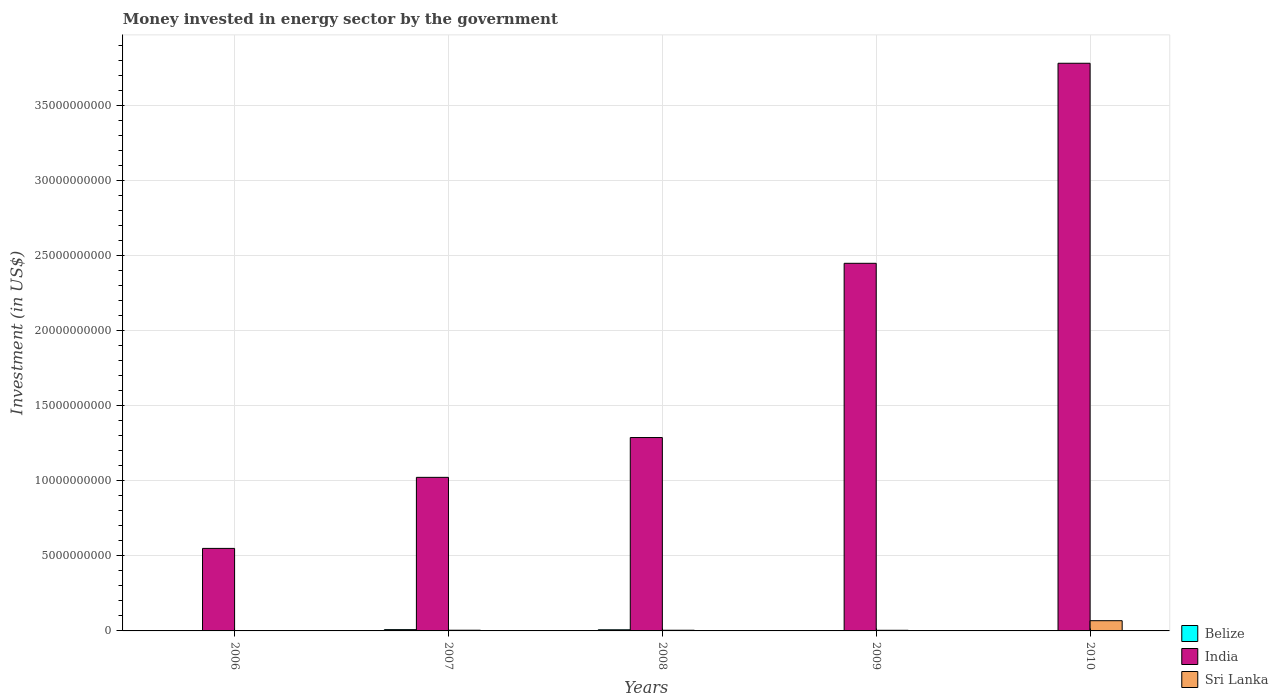Are the number of bars per tick equal to the number of legend labels?
Make the answer very short. Yes. What is the label of the 1st group of bars from the left?
Keep it short and to the point. 2006. In how many cases, is the number of bars for a given year not equal to the number of legend labels?
Provide a succinct answer. 0. What is the money spent in energy sector in Sri Lanka in 2008?
Your answer should be very brief. 4.56e+07. Across all years, what is the maximum money spent in energy sector in Belize?
Provide a succinct answer. 8.55e+07. Across all years, what is the minimum money spent in energy sector in India?
Keep it short and to the point. 5.50e+09. In which year was the money spent in energy sector in Belize maximum?
Make the answer very short. 2007. In which year was the money spent in energy sector in Sri Lanka minimum?
Make the answer very short. 2006. What is the total money spent in energy sector in India in the graph?
Provide a short and direct response. 9.10e+1. What is the difference between the money spent in energy sector in Sri Lanka in 2008 and that in 2010?
Provide a short and direct response. -6.36e+08. What is the difference between the money spent in energy sector in India in 2007 and the money spent in energy sector in Belize in 2006?
Keep it short and to the point. 1.02e+1. What is the average money spent in energy sector in Sri Lanka per year?
Ensure brevity in your answer.  1.63e+08. In the year 2009, what is the difference between the money spent in energy sector in India and money spent in energy sector in Belize?
Your response must be concise. 2.45e+1. In how many years, is the money spent in energy sector in Belize greater than 12000000000 US$?
Provide a short and direct response. 0. What is the ratio of the money spent in energy sector in Sri Lanka in 2006 to that in 2008?
Provide a succinct answer. 0.02. Is the money spent in energy sector in India in 2008 less than that in 2009?
Ensure brevity in your answer.  Yes. What is the difference between the highest and the second highest money spent in energy sector in Sri Lanka?
Offer a very short reply. 6.36e+08. What is the difference between the highest and the lowest money spent in energy sector in India?
Ensure brevity in your answer.  3.23e+1. In how many years, is the money spent in energy sector in India greater than the average money spent in energy sector in India taken over all years?
Offer a very short reply. 2. What does the 3rd bar from the left in 2009 represents?
Make the answer very short. Sri Lanka. What does the 3rd bar from the right in 2010 represents?
Make the answer very short. Belize. Is it the case that in every year, the sum of the money spent in energy sector in India and money spent in energy sector in Sri Lanka is greater than the money spent in energy sector in Belize?
Provide a succinct answer. Yes. How many bars are there?
Make the answer very short. 15. Are all the bars in the graph horizontal?
Your response must be concise. No. Does the graph contain any zero values?
Your answer should be compact. No. Where does the legend appear in the graph?
Provide a short and direct response. Bottom right. What is the title of the graph?
Your answer should be compact. Money invested in energy sector by the government. What is the label or title of the X-axis?
Your response must be concise. Years. What is the label or title of the Y-axis?
Your answer should be very brief. Investment (in US$). What is the Investment (in US$) of Belize in 2006?
Make the answer very short. 1.60e+07. What is the Investment (in US$) in India in 2006?
Your answer should be very brief. 5.50e+09. What is the Investment (in US$) of Sri Lanka in 2006?
Your response must be concise. 1.00e+06. What is the Investment (in US$) of Belize in 2007?
Give a very brief answer. 8.55e+07. What is the Investment (in US$) of India in 2007?
Offer a very short reply. 1.02e+1. What is the Investment (in US$) of Sri Lanka in 2007?
Make the answer very short. 4.60e+07. What is the Investment (in US$) in Belize in 2008?
Your answer should be very brief. 7.50e+07. What is the Investment (in US$) of India in 2008?
Your response must be concise. 1.29e+1. What is the Investment (in US$) of Sri Lanka in 2008?
Give a very brief answer. 4.56e+07. What is the Investment (in US$) in Belize in 2009?
Your response must be concise. 2.15e+07. What is the Investment (in US$) of India in 2009?
Provide a short and direct response. 2.45e+1. What is the Investment (in US$) in Sri Lanka in 2009?
Offer a very short reply. 4.17e+07. What is the Investment (in US$) in Belize in 2010?
Your response must be concise. 2.22e+07. What is the Investment (in US$) of India in 2010?
Offer a very short reply. 3.78e+1. What is the Investment (in US$) of Sri Lanka in 2010?
Provide a short and direct response. 6.82e+08. Across all years, what is the maximum Investment (in US$) of Belize?
Provide a short and direct response. 8.55e+07. Across all years, what is the maximum Investment (in US$) of India?
Your answer should be very brief. 3.78e+1. Across all years, what is the maximum Investment (in US$) of Sri Lanka?
Ensure brevity in your answer.  6.82e+08. Across all years, what is the minimum Investment (in US$) of Belize?
Your response must be concise. 1.60e+07. Across all years, what is the minimum Investment (in US$) in India?
Provide a short and direct response. 5.50e+09. Across all years, what is the minimum Investment (in US$) in Sri Lanka?
Offer a very short reply. 1.00e+06. What is the total Investment (in US$) in Belize in the graph?
Offer a terse response. 2.20e+08. What is the total Investment (in US$) in India in the graph?
Make the answer very short. 9.10e+1. What is the total Investment (in US$) of Sri Lanka in the graph?
Your response must be concise. 8.16e+08. What is the difference between the Investment (in US$) of Belize in 2006 and that in 2007?
Your answer should be compact. -6.95e+07. What is the difference between the Investment (in US$) in India in 2006 and that in 2007?
Give a very brief answer. -4.74e+09. What is the difference between the Investment (in US$) in Sri Lanka in 2006 and that in 2007?
Ensure brevity in your answer.  -4.50e+07. What is the difference between the Investment (in US$) of Belize in 2006 and that in 2008?
Give a very brief answer. -5.90e+07. What is the difference between the Investment (in US$) in India in 2006 and that in 2008?
Give a very brief answer. -7.39e+09. What is the difference between the Investment (in US$) in Sri Lanka in 2006 and that in 2008?
Your answer should be compact. -4.46e+07. What is the difference between the Investment (in US$) in Belize in 2006 and that in 2009?
Your answer should be compact. -5.50e+06. What is the difference between the Investment (in US$) of India in 2006 and that in 2009?
Keep it short and to the point. -1.90e+1. What is the difference between the Investment (in US$) of Sri Lanka in 2006 and that in 2009?
Keep it short and to the point. -4.07e+07. What is the difference between the Investment (in US$) of Belize in 2006 and that in 2010?
Provide a succinct answer. -6.20e+06. What is the difference between the Investment (in US$) of India in 2006 and that in 2010?
Provide a succinct answer. -3.23e+1. What is the difference between the Investment (in US$) in Sri Lanka in 2006 and that in 2010?
Make the answer very short. -6.81e+08. What is the difference between the Investment (in US$) in Belize in 2007 and that in 2008?
Ensure brevity in your answer.  1.05e+07. What is the difference between the Investment (in US$) in India in 2007 and that in 2008?
Give a very brief answer. -2.65e+09. What is the difference between the Investment (in US$) of Sri Lanka in 2007 and that in 2008?
Your answer should be very brief. 3.50e+05. What is the difference between the Investment (in US$) of Belize in 2007 and that in 2009?
Provide a short and direct response. 6.40e+07. What is the difference between the Investment (in US$) of India in 2007 and that in 2009?
Keep it short and to the point. -1.43e+1. What is the difference between the Investment (in US$) of Sri Lanka in 2007 and that in 2009?
Make the answer very short. 4.30e+06. What is the difference between the Investment (in US$) in Belize in 2007 and that in 2010?
Keep it short and to the point. 6.33e+07. What is the difference between the Investment (in US$) of India in 2007 and that in 2010?
Your response must be concise. -2.76e+1. What is the difference between the Investment (in US$) in Sri Lanka in 2007 and that in 2010?
Offer a very short reply. -6.36e+08. What is the difference between the Investment (in US$) of Belize in 2008 and that in 2009?
Keep it short and to the point. 5.35e+07. What is the difference between the Investment (in US$) in India in 2008 and that in 2009?
Make the answer very short. -1.16e+1. What is the difference between the Investment (in US$) in Sri Lanka in 2008 and that in 2009?
Your answer should be compact. 3.95e+06. What is the difference between the Investment (in US$) of Belize in 2008 and that in 2010?
Provide a succinct answer. 5.28e+07. What is the difference between the Investment (in US$) of India in 2008 and that in 2010?
Keep it short and to the point. -2.49e+1. What is the difference between the Investment (in US$) of Sri Lanka in 2008 and that in 2010?
Offer a terse response. -6.36e+08. What is the difference between the Investment (in US$) of Belize in 2009 and that in 2010?
Your answer should be compact. -7.00e+05. What is the difference between the Investment (in US$) of India in 2009 and that in 2010?
Your answer should be very brief. -1.33e+1. What is the difference between the Investment (in US$) of Sri Lanka in 2009 and that in 2010?
Keep it short and to the point. -6.40e+08. What is the difference between the Investment (in US$) in Belize in 2006 and the Investment (in US$) in India in 2007?
Provide a short and direct response. -1.02e+1. What is the difference between the Investment (in US$) of Belize in 2006 and the Investment (in US$) of Sri Lanka in 2007?
Offer a terse response. -3.00e+07. What is the difference between the Investment (in US$) in India in 2006 and the Investment (in US$) in Sri Lanka in 2007?
Keep it short and to the point. 5.45e+09. What is the difference between the Investment (in US$) in Belize in 2006 and the Investment (in US$) in India in 2008?
Your answer should be very brief. -1.29e+1. What is the difference between the Investment (in US$) in Belize in 2006 and the Investment (in US$) in Sri Lanka in 2008?
Give a very brief answer. -2.96e+07. What is the difference between the Investment (in US$) in India in 2006 and the Investment (in US$) in Sri Lanka in 2008?
Ensure brevity in your answer.  5.46e+09. What is the difference between the Investment (in US$) in Belize in 2006 and the Investment (in US$) in India in 2009?
Your response must be concise. -2.45e+1. What is the difference between the Investment (in US$) of Belize in 2006 and the Investment (in US$) of Sri Lanka in 2009?
Keep it short and to the point. -2.57e+07. What is the difference between the Investment (in US$) of India in 2006 and the Investment (in US$) of Sri Lanka in 2009?
Provide a succinct answer. 5.46e+09. What is the difference between the Investment (in US$) in Belize in 2006 and the Investment (in US$) in India in 2010?
Ensure brevity in your answer.  -3.78e+1. What is the difference between the Investment (in US$) of Belize in 2006 and the Investment (in US$) of Sri Lanka in 2010?
Your answer should be compact. -6.66e+08. What is the difference between the Investment (in US$) in India in 2006 and the Investment (in US$) in Sri Lanka in 2010?
Ensure brevity in your answer.  4.82e+09. What is the difference between the Investment (in US$) in Belize in 2007 and the Investment (in US$) in India in 2008?
Offer a terse response. -1.28e+1. What is the difference between the Investment (in US$) in Belize in 2007 and the Investment (in US$) in Sri Lanka in 2008?
Your response must be concise. 3.98e+07. What is the difference between the Investment (in US$) of India in 2007 and the Investment (in US$) of Sri Lanka in 2008?
Keep it short and to the point. 1.02e+1. What is the difference between the Investment (in US$) of Belize in 2007 and the Investment (in US$) of India in 2009?
Offer a very short reply. -2.44e+1. What is the difference between the Investment (in US$) in Belize in 2007 and the Investment (in US$) in Sri Lanka in 2009?
Make the answer very short. 4.38e+07. What is the difference between the Investment (in US$) of India in 2007 and the Investment (in US$) of Sri Lanka in 2009?
Your answer should be compact. 1.02e+1. What is the difference between the Investment (in US$) of Belize in 2007 and the Investment (in US$) of India in 2010?
Make the answer very short. -3.78e+1. What is the difference between the Investment (in US$) of Belize in 2007 and the Investment (in US$) of Sri Lanka in 2010?
Provide a succinct answer. -5.96e+08. What is the difference between the Investment (in US$) in India in 2007 and the Investment (in US$) in Sri Lanka in 2010?
Ensure brevity in your answer.  9.55e+09. What is the difference between the Investment (in US$) of Belize in 2008 and the Investment (in US$) of India in 2009?
Ensure brevity in your answer.  -2.44e+1. What is the difference between the Investment (in US$) of Belize in 2008 and the Investment (in US$) of Sri Lanka in 2009?
Offer a terse response. 3.33e+07. What is the difference between the Investment (in US$) in India in 2008 and the Investment (in US$) in Sri Lanka in 2009?
Your answer should be compact. 1.28e+1. What is the difference between the Investment (in US$) in Belize in 2008 and the Investment (in US$) in India in 2010?
Make the answer very short. -3.78e+1. What is the difference between the Investment (in US$) in Belize in 2008 and the Investment (in US$) in Sri Lanka in 2010?
Your answer should be very brief. -6.07e+08. What is the difference between the Investment (in US$) in India in 2008 and the Investment (in US$) in Sri Lanka in 2010?
Offer a very short reply. 1.22e+1. What is the difference between the Investment (in US$) of Belize in 2009 and the Investment (in US$) of India in 2010?
Provide a succinct answer. -3.78e+1. What is the difference between the Investment (in US$) of Belize in 2009 and the Investment (in US$) of Sri Lanka in 2010?
Your answer should be very brief. -6.60e+08. What is the difference between the Investment (in US$) of India in 2009 and the Investment (in US$) of Sri Lanka in 2010?
Offer a terse response. 2.38e+1. What is the average Investment (in US$) in Belize per year?
Give a very brief answer. 4.40e+07. What is the average Investment (in US$) in India per year?
Offer a very short reply. 1.82e+1. What is the average Investment (in US$) of Sri Lanka per year?
Give a very brief answer. 1.63e+08. In the year 2006, what is the difference between the Investment (in US$) in Belize and Investment (in US$) in India?
Provide a short and direct response. -5.48e+09. In the year 2006, what is the difference between the Investment (in US$) in Belize and Investment (in US$) in Sri Lanka?
Your answer should be compact. 1.50e+07. In the year 2006, what is the difference between the Investment (in US$) of India and Investment (in US$) of Sri Lanka?
Provide a succinct answer. 5.50e+09. In the year 2007, what is the difference between the Investment (in US$) of Belize and Investment (in US$) of India?
Give a very brief answer. -1.02e+1. In the year 2007, what is the difference between the Investment (in US$) of Belize and Investment (in US$) of Sri Lanka?
Offer a terse response. 3.95e+07. In the year 2007, what is the difference between the Investment (in US$) in India and Investment (in US$) in Sri Lanka?
Ensure brevity in your answer.  1.02e+1. In the year 2008, what is the difference between the Investment (in US$) of Belize and Investment (in US$) of India?
Give a very brief answer. -1.28e+1. In the year 2008, what is the difference between the Investment (in US$) of Belize and Investment (in US$) of Sri Lanka?
Give a very brief answer. 2.94e+07. In the year 2008, what is the difference between the Investment (in US$) of India and Investment (in US$) of Sri Lanka?
Your answer should be compact. 1.28e+1. In the year 2009, what is the difference between the Investment (in US$) of Belize and Investment (in US$) of India?
Offer a very short reply. -2.45e+1. In the year 2009, what is the difference between the Investment (in US$) in Belize and Investment (in US$) in Sri Lanka?
Keep it short and to the point. -2.02e+07. In the year 2009, what is the difference between the Investment (in US$) in India and Investment (in US$) in Sri Lanka?
Provide a short and direct response. 2.45e+1. In the year 2010, what is the difference between the Investment (in US$) of Belize and Investment (in US$) of India?
Your answer should be very brief. -3.78e+1. In the year 2010, what is the difference between the Investment (in US$) of Belize and Investment (in US$) of Sri Lanka?
Offer a very short reply. -6.59e+08. In the year 2010, what is the difference between the Investment (in US$) in India and Investment (in US$) in Sri Lanka?
Make the answer very short. 3.72e+1. What is the ratio of the Investment (in US$) of Belize in 2006 to that in 2007?
Your answer should be very brief. 0.19. What is the ratio of the Investment (in US$) in India in 2006 to that in 2007?
Ensure brevity in your answer.  0.54. What is the ratio of the Investment (in US$) of Sri Lanka in 2006 to that in 2007?
Ensure brevity in your answer.  0.02. What is the ratio of the Investment (in US$) of Belize in 2006 to that in 2008?
Provide a short and direct response. 0.21. What is the ratio of the Investment (in US$) of India in 2006 to that in 2008?
Your response must be concise. 0.43. What is the ratio of the Investment (in US$) of Sri Lanka in 2006 to that in 2008?
Keep it short and to the point. 0.02. What is the ratio of the Investment (in US$) of Belize in 2006 to that in 2009?
Provide a short and direct response. 0.74. What is the ratio of the Investment (in US$) in India in 2006 to that in 2009?
Your answer should be very brief. 0.22. What is the ratio of the Investment (in US$) of Sri Lanka in 2006 to that in 2009?
Give a very brief answer. 0.02. What is the ratio of the Investment (in US$) of Belize in 2006 to that in 2010?
Make the answer very short. 0.72. What is the ratio of the Investment (in US$) of India in 2006 to that in 2010?
Your answer should be compact. 0.15. What is the ratio of the Investment (in US$) in Sri Lanka in 2006 to that in 2010?
Your answer should be compact. 0. What is the ratio of the Investment (in US$) in Belize in 2007 to that in 2008?
Give a very brief answer. 1.14. What is the ratio of the Investment (in US$) in India in 2007 to that in 2008?
Keep it short and to the point. 0.79. What is the ratio of the Investment (in US$) in Sri Lanka in 2007 to that in 2008?
Offer a terse response. 1.01. What is the ratio of the Investment (in US$) in Belize in 2007 to that in 2009?
Your answer should be compact. 3.98. What is the ratio of the Investment (in US$) of India in 2007 to that in 2009?
Your response must be concise. 0.42. What is the ratio of the Investment (in US$) in Sri Lanka in 2007 to that in 2009?
Offer a terse response. 1.1. What is the ratio of the Investment (in US$) of Belize in 2007 to that in 2010?
Offer a terse response. 3.85. What is the ratio of the Investment (in US$) in India in 2007 to that in 2010?
Make the answer very short. 0.27. What is the ratio of the Investment (in US$) in Sri Lanka in 2007 to that in 2010?
Your answer should be compact. 0.07. What is the ratio of the Investment (in US$) in Belize in 2008 to that in 2009?
Provide a short and direct response. 3.49. What is the ratio of the Investment (in US$) of India in 2008 to that in 2009?
Your response must be concise. 0.53. What is the ratio of the Investment (in US$) in Sri Lanka in 2008 to that in 2009?
Your answer should be compact. 1.09. What is the ratio of the Investment (in US$) of Belize in 2008 to that in 2010?
Offer a very short reply. 3.38. What is the ratio of the Investment (in US$) in India in 2008 to that in 2010?
Keep it short and to the point. 0.34. What is the ratio of the Investment (in US$) of Sri Lanka in 2008 to that in 2010?
Provide a succinct answer. 0.07. What is the ratio of the Investment (in US$) in Belize in 2009 to that in 2010?
Your answer should be very brief. 0.97. What is the ratio of the Investment (in US$) in India in 2009 to that in 2010?
Offer a terse response. 0.65. What is the ratio of the Investment (in US$) in Sri Lanka in 2009 to that in 2010?
Provide a succinct answer. 0.06. What is the difference between the highest and the second highest Investment (in US$) of Belize?
Provide a short and direct response. 1.05e+07. What is the difference between the highest and the second highest Investment (in US$) in India?
Make the answer very short. 1.33e+1. What is the difference between the highest and the second highest Investment (in US$) in Sri Lanka?
Your answer should be compact. 6.36e+08. What is the difference between the highest and the lowest Investment (in US$) of Belize?
Offer a terse response. 6.95e+07. What is the difference between the highest and the lowest Investment (in US$) in India?
Ensure brevity in your answer.  3.23e+1. What is the difference between the highest and the lowest Investment (in US$) of Sri Lanka?
Make the answer very short. 6.81e+08. 